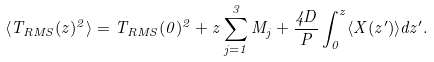<formula> <loc_0><loc_0><loc_500><loc_500>\langle T _ { R M S } ( z ) ^ { 2 } \rangle = T _ { R M S } ( 0 ) ^ { 2 } + z \sum _ { j = 1 } ^ { 3 } M _ { j } + \frac { 4 D } { P } \int _ { 0 } ^ { z } \langle X ( z ^ { \prime } ) \rangle d z ^ { \prime } .</formula> 